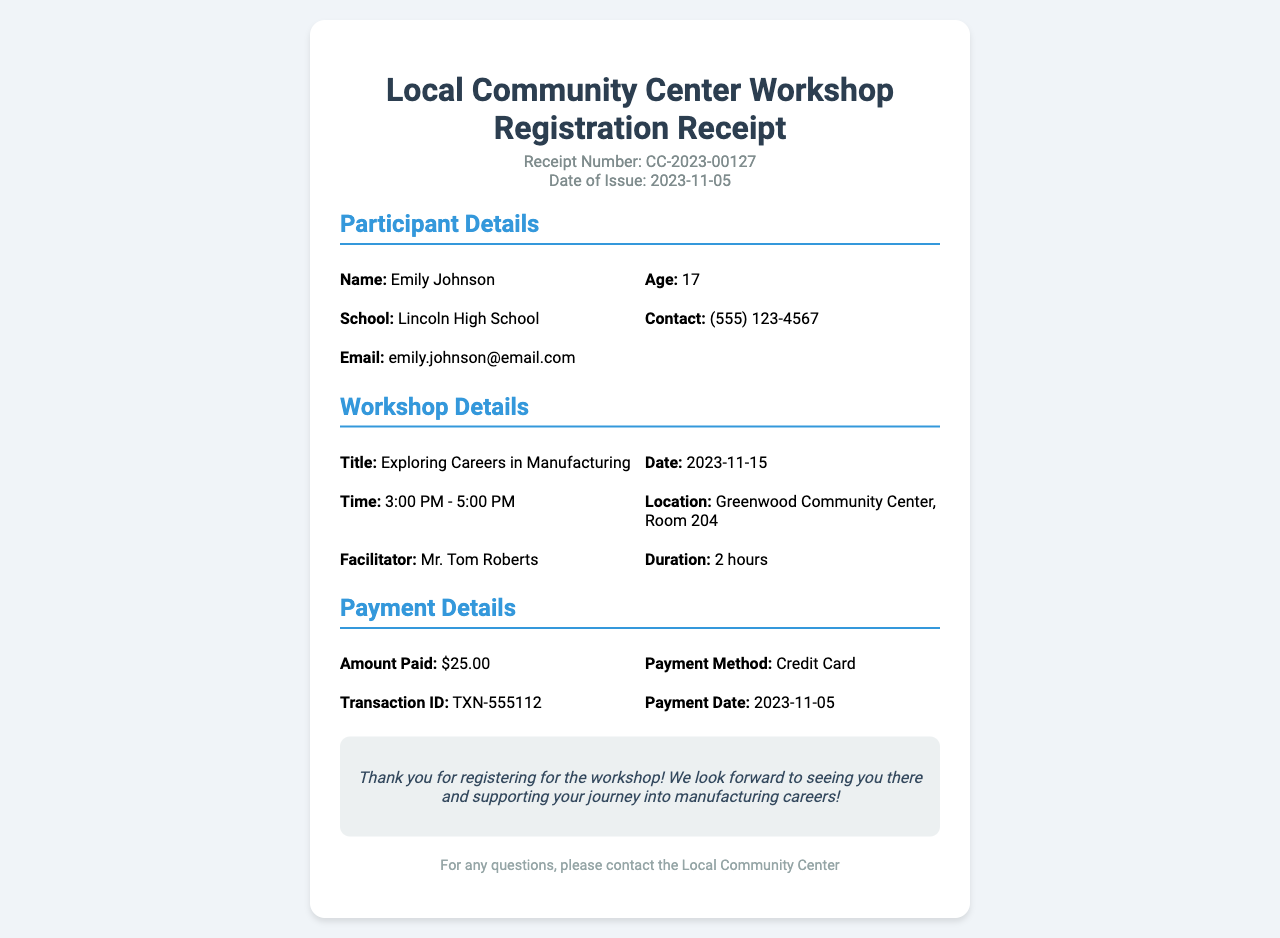What is the receipt number? The receipt number is listed in the header of the document as a unique identifier for the registration.
Answer: CC-2023-00127 Who is the participant? The participant's name, provided under the participant details section, indicates who registered for the workshop.
Answer: Emily Johnson What is the title of the workshop? The title of the workshop is stated clearly in the workshop details section, highlighting the focus of the event.
Answer: Exploring Careers in Manufacturing When does the workshop take place? The date of the workshop is specified in the workshop details section, providing the exact scheduled date.
Answer: 2023-11-15 What is the amount paid for the workshop? The payment details section indicates how much was paid for the registration of the workshop.
Answer: $25.00 Who is the facilitator of the workshop? The facilitator's name is mentioned in the workshop details section, indicating who will be leading the session.
Answer: Mr. Tom Roberts How long is the workshop scheduled to last? The duration of the workshop is specifically mentioned under the workshop details, providing insight into the length of the session.
Answer: 2 hours What payment method was used for registration? The payment method is detailed in the payment section, describing how the payment was processed.
Answer: Credit Card What is the contact number for the community center? The document mentions a contact method for inquiries, which can be assumed to include a contact number as part of the community center details.
Answer: (555) 123-4567 